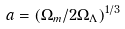Convert formula to latex. <formula><loc_0><loc_0><loc_500><loc_500>a = ( \Omega _ { m } / 2 \Omega _ { \Lambda } ) ^ { 1 / 3 }</formula> 